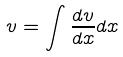Convert formula to latex. <formula><loc_0><loc_0><loc_500><loc_500>v = \int \frac { d v } { d x } d x</formula> 